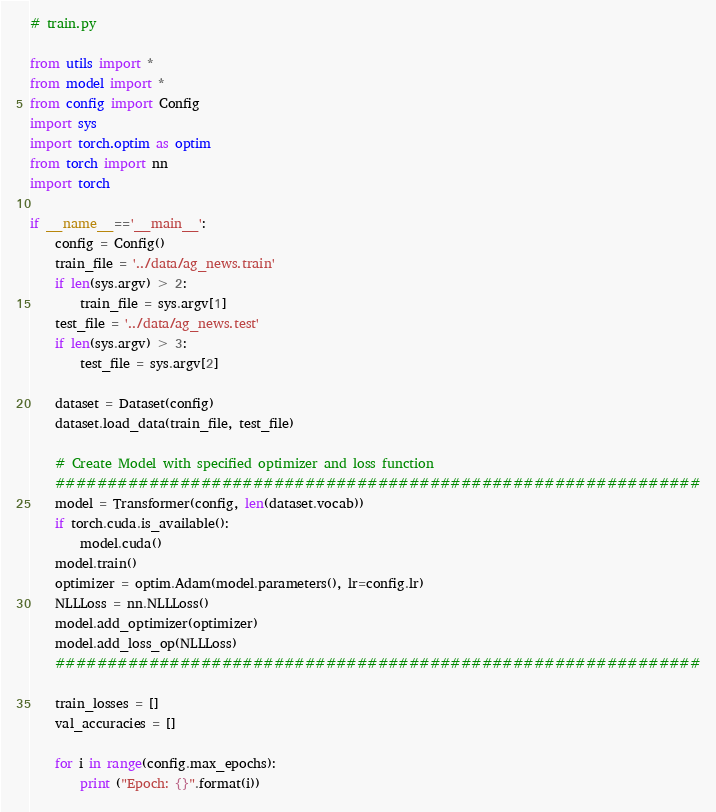Convert code to text. <code><loc_0><loc_0><loc_500><loc_500><_Python_># train.py

from utils import *
from model import *
from config import Config
import sys
import torch.optim as optim
from torch import nn
import torch

if __name__=='__main__':
    config = Config()
    train_file = '../data/ag_news.train'
    if len(sys.argv) > 2:
        train_file = sys.argv[1]
    test_file = '../data/ag_news.test'
    if len(sys.argv) > 3:
        test_file = sys.argv[2]
    
    dataset = Dataset(config)
    dataset.load_data(train_file, test_file)
    
    # Create Model with specified optimizer and loss function
    ##############################################################
    model = Transformer(config, len(dataset.vocab))
    if torch.cuda.is_available():
        model.cuda()
    model.train()
    optimizer = optim.Adam(model.parameters(), lr=config.lr)
    NLLLoss = nn.NLLLoss()
    model.add_optimizer(optimizer)
    model.add_loss_op(NLLLoss)
    ##############################################################
    
    train_losses = []
    val_accuracies = []
    
    for i in range(config.max_epochs):
        print ("Epoch: {}".format(i))</code> 